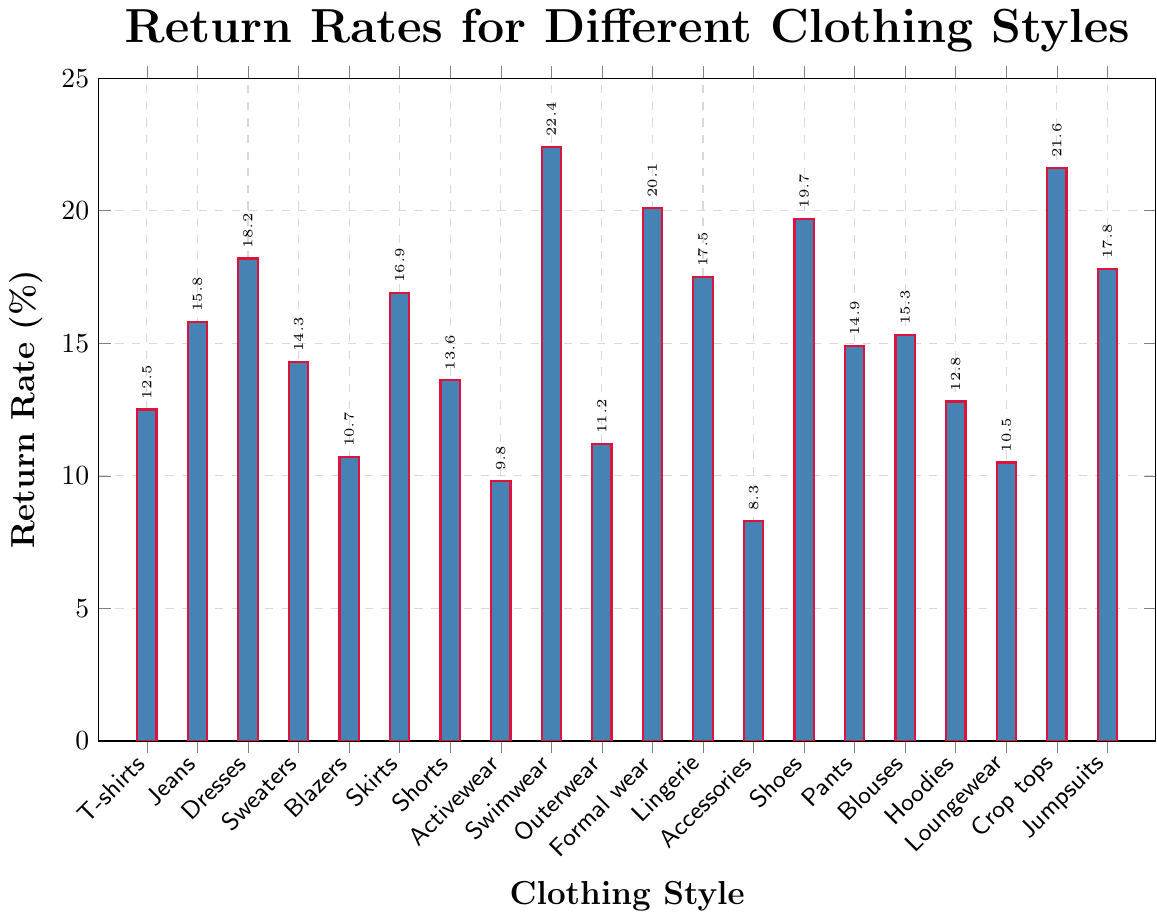Which clothing style has the highest return rate? By examining the lengths of the bars in the chart, Swimwear has the tallest bar, indicating it has the highest return rate among all styles listed.
Answer: Swimwear Which has a lower return rate, Blazers or Blouses? Comparing the bar heights of Blazers and Blouses, we see that Blazers have a shorter bar than Blouses. Thus, Blazers have a lower return rate.
Answer: Blazers Is the return rate for Shoes higher or lower than that for Pants? Observing the bars for Shoes and Pants, the bar for Shoes is taller than the one for Pants, indicating that Shoes have a higher return rate than Pants.
Answer: Higher What are the three styles with the lowest return rates? Identifying the shortest bars, Activewear, Accessories, and Loungewear have the lowest return rates among the clothing styles.
Answer: Activewear, Accessories, Loungewear What is the difference in return rates between the clothing style with the highest rate and the style with the lowest rate? The highest return rate is for Swimwear at 22.4%, and the lowest is for Accessories at 8.3%. The difference is 22.4% - 8.3% = 14.1%.
Answer: 14.1% What is the average return rate of Swimwear, Formal wear, and Crop tops? The return rates are Swimwear (22.4%), Formal wear (20.1%), and Crop tops (21.6%). Summing these up gives 22.4 + 20.1 + 21.6 = 64.1, and dividing by 3 gives an average of 64.1 / 3 = 21.37.
Answer: 21.37% Which clothing styles have a return rate greater than 18% but less than 22%? Examining the bars, Dresses (18.2%), Swimwear (22.4%), Formal wear (20.1%), Crop tops (21.6%), and Shoes (19.7%) fit within this range, but Swimwear is exactly 22.4% and thus excluded. The final list is Dresses, Formal wear, Crop tops, and Shoes.
Answer: Dresses, Formal wear, Crop tops, Shoes What percentage more is the return rate for Dresses compared to T-shirts? The return rate for Dresses is 18.2%, and for T-shirts, it's 12.5%. The difference is 18.2% - 12.5% = 5.7%. The percentage more is (5.7 / 12.5) * 100 = 45.6%.
Answer: 45.6% Are the return rates of pants and jeans closer to each other compared to that of blouses and skirts? The return rates of Pants (14.9%) and Jeans (15.8%) have a difference of 15.8 - 14.9 = 0.9%. The return rates of Blouses (15.3%) and Skirts (16.9%) have a difference of 16.9 - 15.3 = 1.6%. The difference between Pants and Jeans is smaller, making them closer to each other compared to Blouses and Skirts.
Answer: Yes 